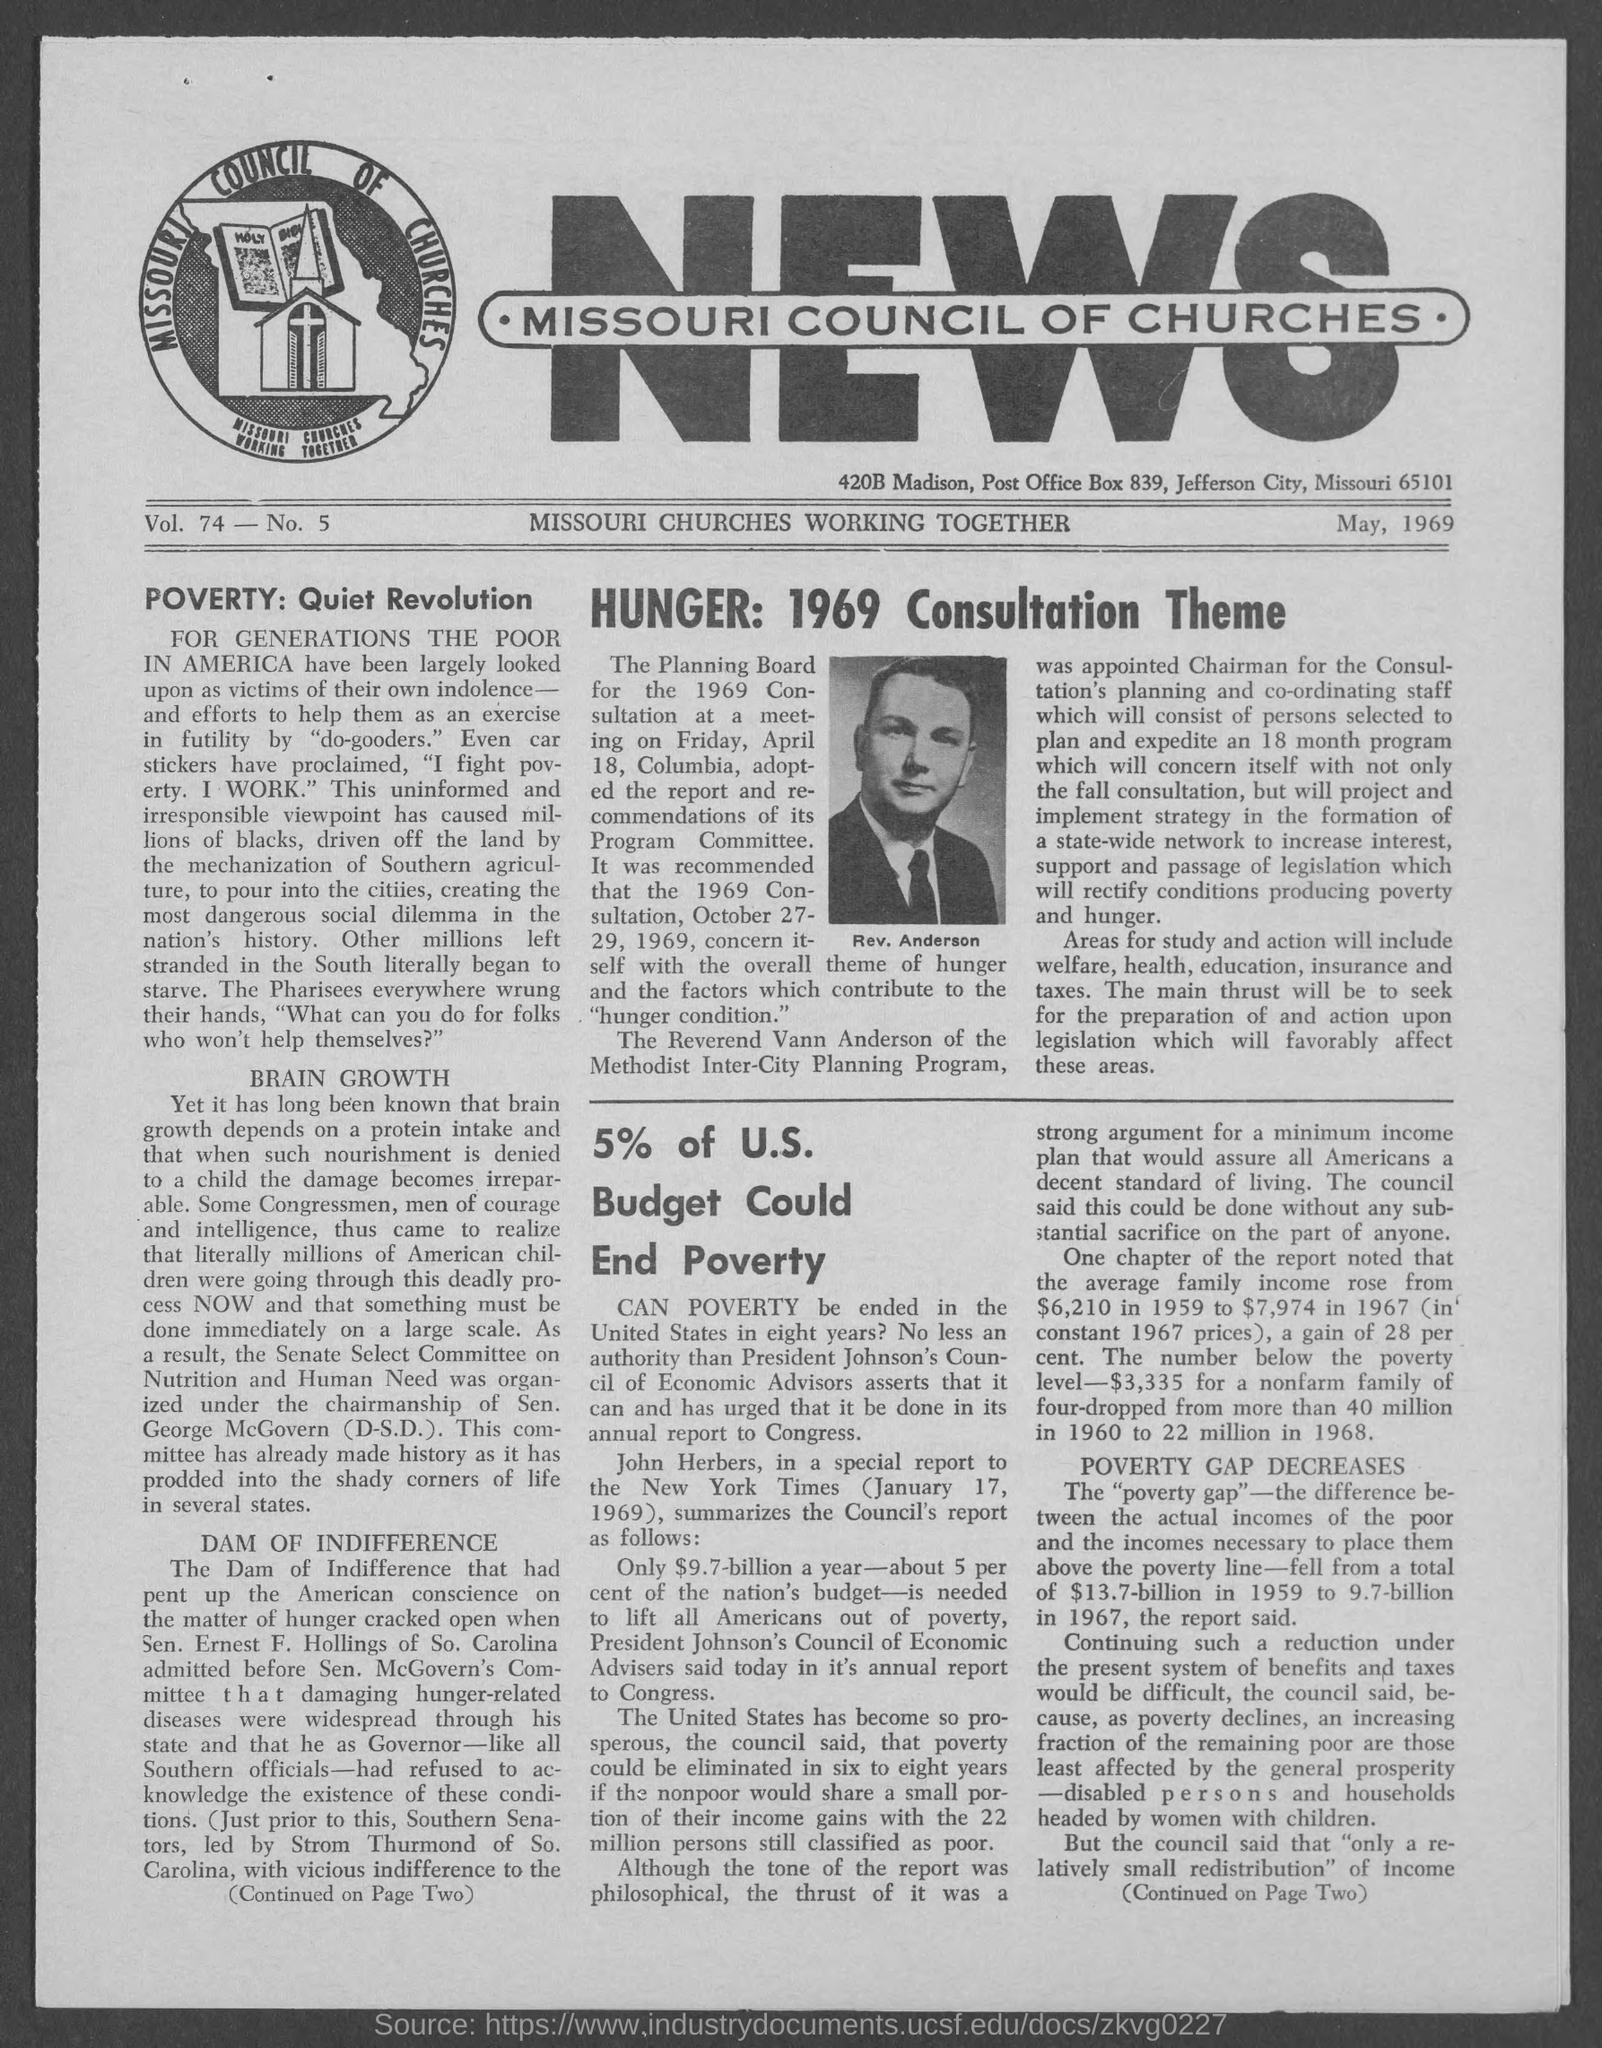Outline some significant characteristics in this image. The volume is 74... The Planning Board for the 1969 Consultation meeting will be held on Friday, April 18th. The date on the document is May 1969. 